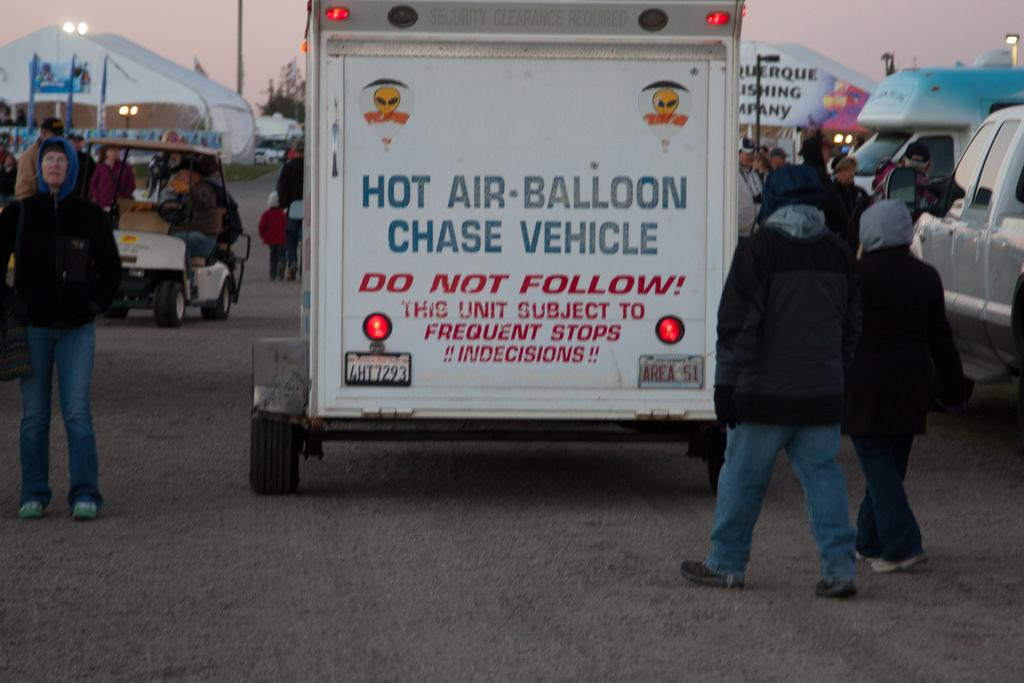Who or what can be seen in the image? There are people in the image. What else is present in the image besides people? There are vehicles on the road in the image, and some people are sitting in the vehicles. What can be seen in the background of the image? There are poles, trees, and the sky visible in the background of the image. What type of hair can be seen on the snail in the image? There is no snail present in the image, so there is no hair to observe. 